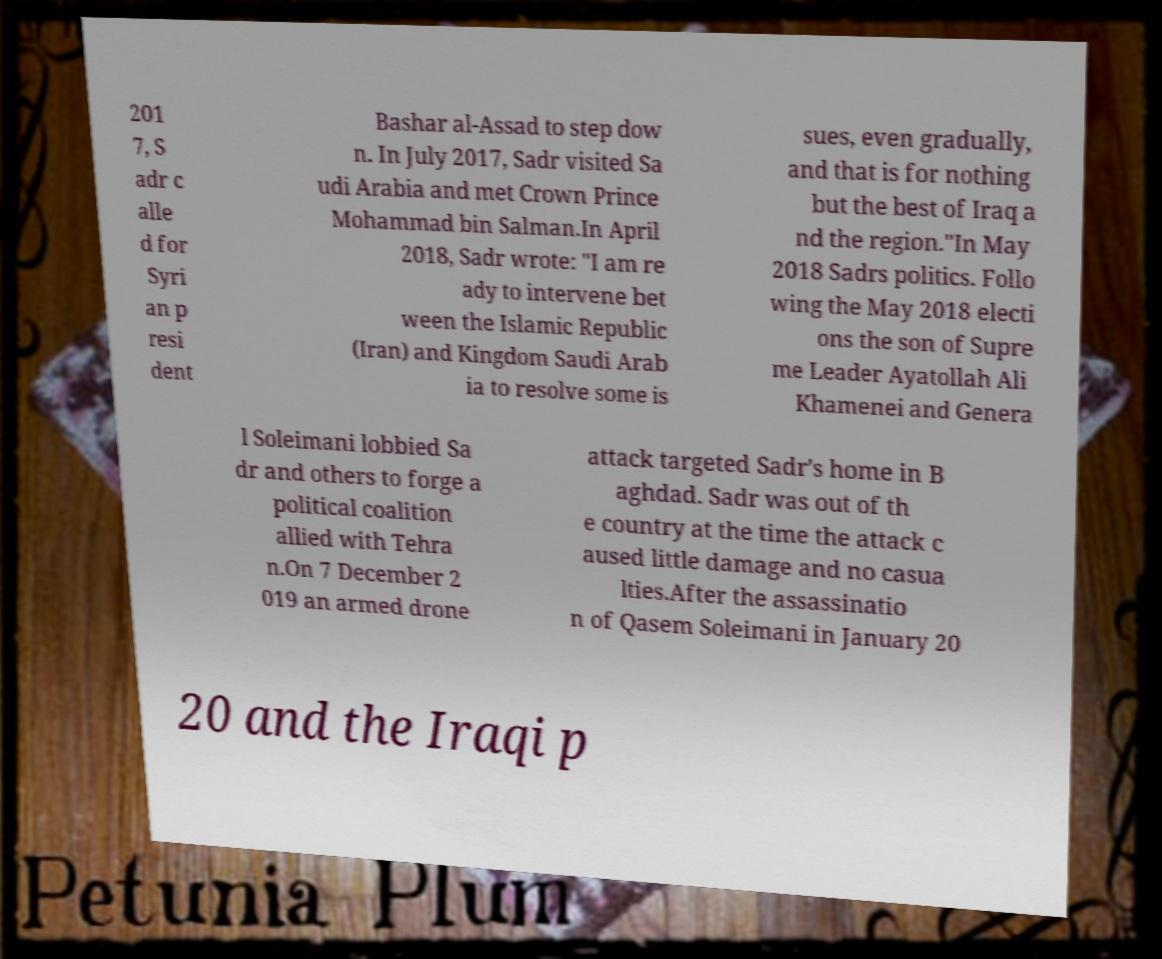Can you read and provide the text displayed in the image?This photo seems to have some interesting text. Can you extract and type it out for me? 201 7, S adr c alle d for Syri an p resi dent Bashar al-Assad to step dow n. In July 2017, Sadr visited Sa udi Arabia and met Crown Prince Mohammad bin Salman.In April 2018, Sadr wrote: "I am re ady to intervene bet ween the Islamic Republic (Iran) and Kingdom Saudi Arab ia to resolve some is sues, even gradually, and that is for nothing but the best of Iraq a nd the region."In May 2018 Sadrs politics. Follo wing the May 2018 electi ons the son of Supre me Leader Ayatollah Ali Khamenei and Genera l Soleimani lobbied Sa dr and others to forge a political coalition allied with Tehra n.On 7 December 2 019 an armed drone attack targeted Sadr's home in B aghdad. Sadr was out of th e country at the time the attack c aused little damage and no casua lties.After the assassinatio n of Qasem Soleimani in January 20 20 and the Iraqi p 